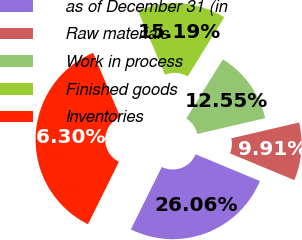<chart> <loc_0><loc_0><loc_500><loc_500><pie_chart><fcel>as of December 31 (in<fcel>Raw materials<fcel>Work in process<fcel>Finished goods<fcel>Inventories<nl><fcel>26.06%<fcel>9.91%<fcel>12.55%<fcel>15.19%<fcel>36.3%<nl></chart> 